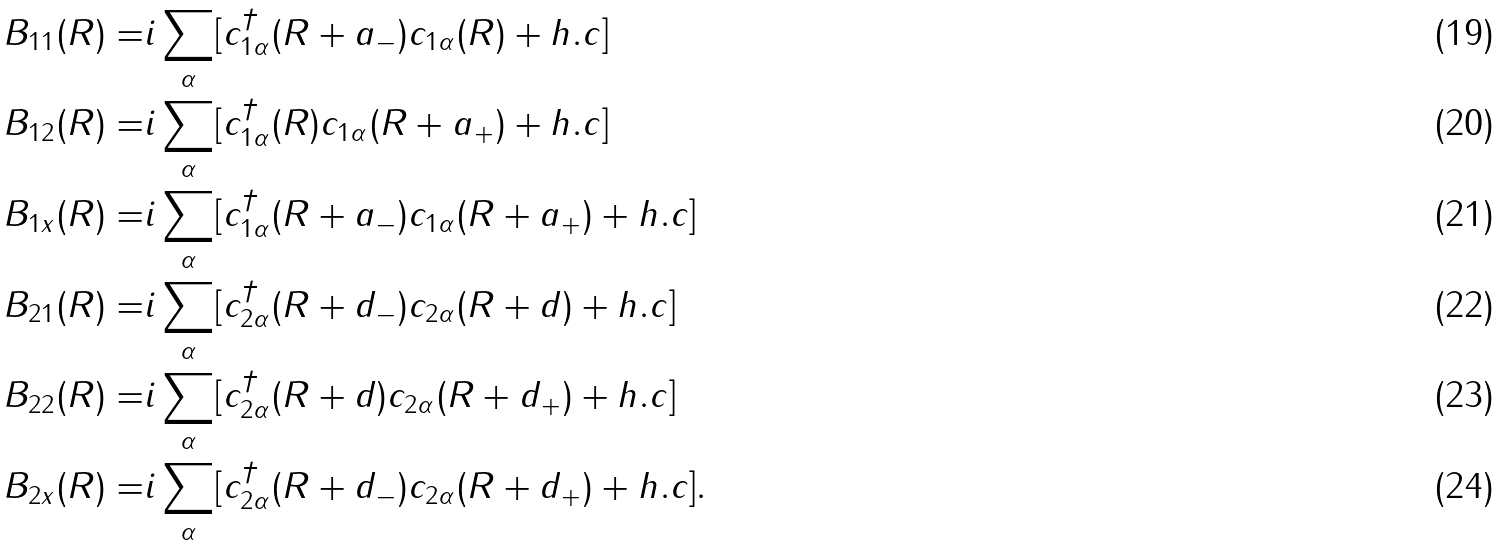<formula> <loc_0><loc_0><loc_500><loc_500>B _ { 1 1 } ( R ) = & i \sum _ { \alpha } [ c ^ { \dag } _ { 1 \alpha } ( R + a _ { - } ) c _ { 1 \alpha } ( R ) + h . c ] \\ B _ { 1 2 } ( R ) = & i \sum _ { \alpha } [ c ^ { \dag } _ { 1 \alpha } ( R ) c _ { 1 \alpha } ( R + a _ { + } ) + h . c ] \\ B _ { 1 x } ( R ) = & i \sum _ { \alpha } [ c ^ { \dag } _ { 1 \alpha } ( R + a _ { - } ) c _ { 1 \alpha } ( R + a _ { + } ) + h . c ] \\ B _ { 2 1 } ( R ) = & i \sum _ { \alpha } [ c ^ { \dag } _ { 2 \alpha } ( R + d _ { - } ) c _ { 2 \alpha } ( R + d ) + h . c ] \\ B _ { 2 2 } ( R ) = & i \sum _ { \alpha } [ c ^ { \dag } _ { 2 \alpha } ( R + d ) c _ { 2 \alpha } ( R + d _ { + } ) + h . c ] \\ B _ { 2 x } ( R ) = & i \sum _ { \alpha } [ c ^ { \dag } _ { 2 \alpha } ( R + d _ { - } ) c _ { 2 \alpha } ( R + d _ { + } ) + h . c ] .</formula> 